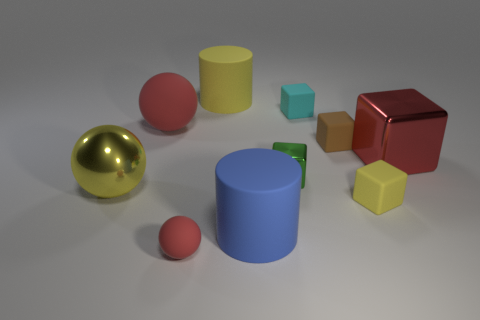Subtract all large rubber spheres. How many spheres are left? 2 Subtract all blue cubes. How many red balls are left? 2 Subtract all cyan blocks. How many blocks are left? 4 Subtract 3 cubes. How many cubes are left? 2 Subtract all gray blocks. Subtract all green spheres. How many blocks are left? 5 Subtract all spheres. How many objects are left? 7 Add 8 big yellow spheres. How many big yellow spheres are left? 9 Add 9 green metallic blocks. How many green metallic blocks exist? 10 Subtract 0 brown cylinders. How many objects are left? 10 Subtract all tiny red cylinders. Subtract all tiny yellow blocks. How many objects are left? 9 